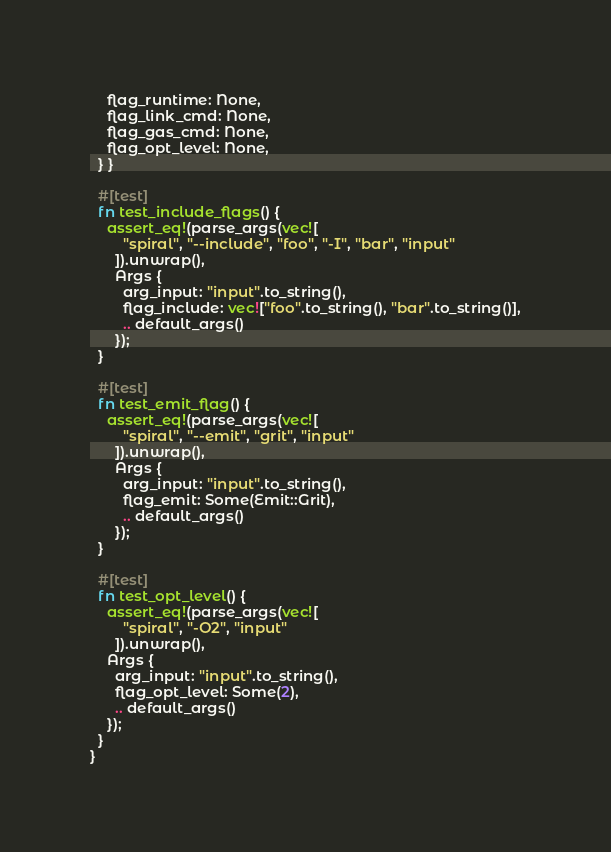Convert code to text. <code><loc_0><loc_0><loc_500><loc_500><_Rust_>    flag_runtime: None,
    flag_link_cmd: None,
    flag_gas_cmd: None,
    flag_opt_level: None,
  } }

  #[test]
  fn test_include_flags() {
    assert_eq!(parse_args(vec![
        "spiral", "--include", "foo", "-I", "bar", "input"
      ]).unwrap(),
      Args {
        arg_input: "input".to_string(),
        flag_include: vec!["foo".to_string(), "bar".to_string()],
        .. default_args()
      });
  }

  #[test]
  fn test_emit_flag() {
    assert_eq!(parse_args(vec![
        "spiral", "--emit", "grit", "input"
      ]).unwrap(),
      Args {
        arg_input: "input".to_string(),
        flag_emit: Some(Emit::Grit),
        .. default_args()
      });
  }

  #[test]
  fn test_opt_level() {
    assert_eq!(parse_args(vec![
        "spiral", "-O2", "input"
      ]).unwrap(),
    Args {
      arg_input: "input".to_string(),
      flag_opt_level: Some(2),
      .. default_args()
    });
  }
}
</code> 